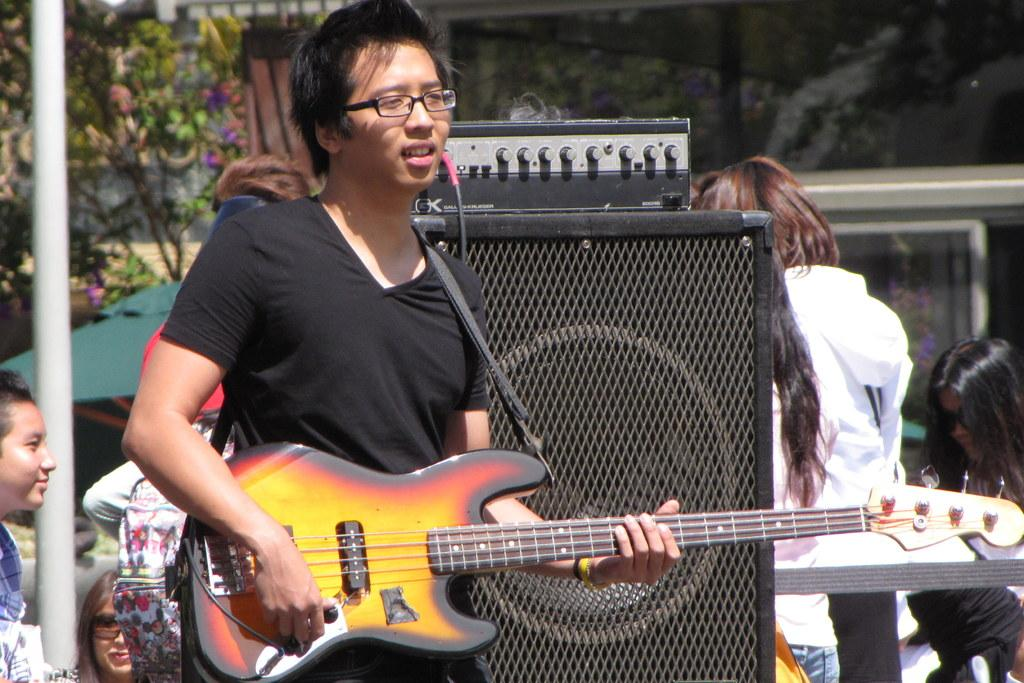What is the person standing in the image holding? The person is holding a guitar. What else can be seen in the image besides the person with the guitar? There are speakers visible in the image. Are there any other people present in the image? Yes, there are other persons in the image. What type of natural vegetation is visible in the image? There are trees visible in the image. Where is the seat located in the image? There is no seat present in the image. What type of notebook is the person using to write down the lyrics? There is no notebook present in the image. What is the sponge being used for in the image? There is no sponge present in the image. 